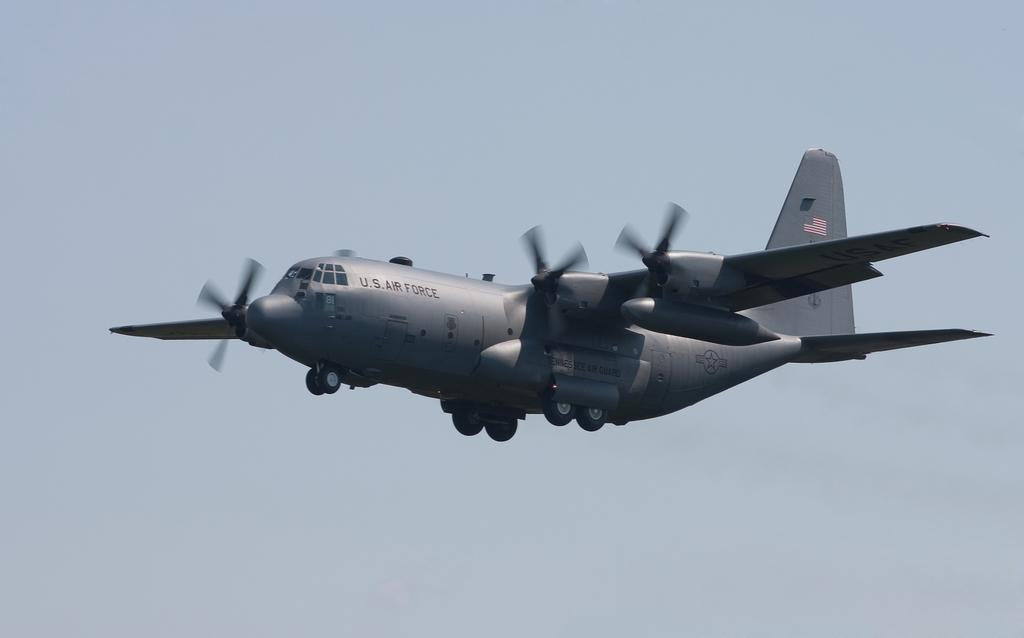Where was the image taken? The image was taken outdoors. What can be seen in the background of the image? The sky is visible in the background of the image. What is happening in the sky in the middle of the image? An airplane is flying in the sky in the middle of the image. How many icicles are hanging from the airplane in the image? There are no icicles present in the image; it features an airplane flying in the sky. What is the airplane's attention focused on in the image? The airplane does not have the ability to have attention, as it is an inanimate object. 